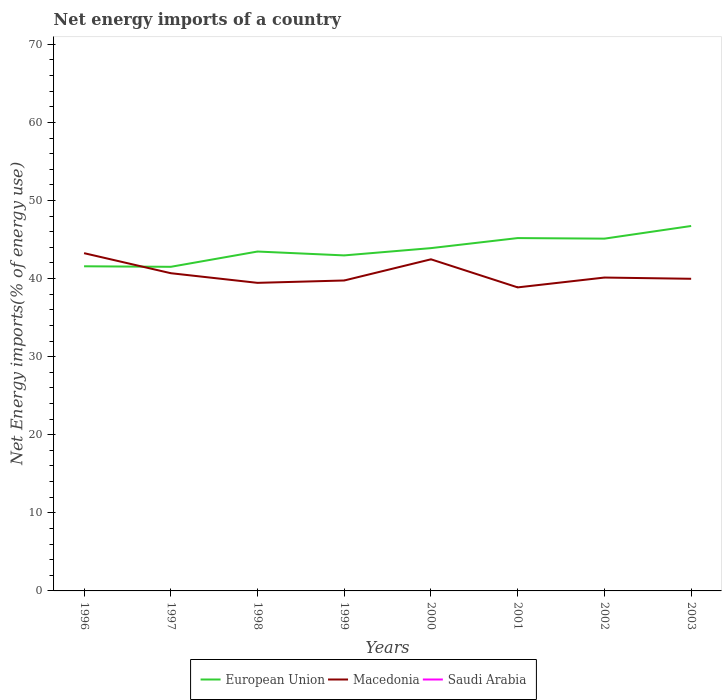How many different coloured lines are there?
Your answer should be very brief. 2. Is the number of lines equal to the number of legend labels?
Keep it short and to the point. No. What is the total net energy imports in European Union in the graph?
Make the answer very short. -1.29. What is the difference between the highest and the second highest net energy imports in Macedonia?
Ensure brevity in your answer.  4.38. What is the difference between the highest and the lowest net energy imports in Saudi Arabia?
Keep it short and to the point. 0. How many lines are there?
Make the answer very short. 2. What is the difference between two consecutive major ticks on the Y-axis?
Your answer should be compact. 10. Does the graph contain any zero values?
Keep it short and to the point. Yes. Does the graph contain grids?
Provide a succinct answer. No. How many legend labels are there?
Provide a succinct answer. 3. How are the legend labels stacked?
Offer a very short reply. Horizontal. What is the title of the graph?
Provide a succinct answer. Net energy imports of a country. What is the label or title of the X-axis?
Offer a terse response. Years. What is the label or title of the Y-axis?
Provide a short and direct response. Net Energy imports(% of energy use). What is the Net Energy imports(% of energy use) of European Union in 1996?
Your answer should be very brief. 41.58. What is the Net Energy imports(% of energy use) in Macedonia in 1996?
Keep it short and to the point. 43.26. What is the Net Energy imports(% of energy use) of Saudi Arabia in 1996?
Keep it short and to the point. 0. What is the Net Energy imports(% of energy use) of European Union in 1997?
Give a very brief answer. 41.51. What is the Net Energy imports(% of energy use) in Macedonia in 1997?
Make the answer very short. 40.69. What is the Net Energy imports(% of energy use) in European Union in 1998?
Your answer should be compact. 43.47. What is the Net Energy imports(% of energy use) of Macedonia in 1998?
Give a very brief answer. 39.46. What is the Net Energy imports(% of energy use) in Saudi Arabia in 1998?
Provide a short and direct response. 0. What is the Net Energy imports(% of energy use) of European Union in 1999?
Keep it short and to the point. 42.97. What is the Net Energy imports(% of energy use) in Macedonia in 1999?
Make the answer very short. 39.76. What is the Net Energy imports(% of energy use) of Saudi Arabia in 1999?
Your answer should be very brief. 0. What is the Net Energy imports(% of energy use) of European Union in 2000?
Offer a very short reply. 43.9. What is the Net Energy imports(% of energy use) of Macedonia in 2000?
Give a very brief answer. 42.47. What is the Net Energy imports(% of energy use) in Saudi Arabia in 2000?
Offer a terse response. 0. What is the Net Energy imports(% of energy use) in European Union in 2001?
Keep it short and to the point. 45.19. What is the Net Energy imports(% of energy use) of Macedonia in 2001?
Your response must be concise. 38.87. What is the Net Energy imports(% of energy use) of Saudi Arabia in 2001?
Provide a succinct answer. 0. What is the Net Energy imports(% of energy use) in European Union in 2002?
Offer a very short reply. 45.12. What is the Net Energy imports(% of energy use) of Macedonia in 2002?
Provide a succinct answer. 40.14. What is the Net Energy imports(% of energy use) in Saudi Arabia in 2002?
Provide a succinct answer. 0. What is the Net Energy imports(% of energy use) in European Union in 2003?
Your answer should be very brief. 46.74. What is the Net Energy imports(% of energy use) in Macedonia in 2003?
Make the answer very short. 39.98. What is the Net Energy imports(% of energy use) of Saudi Arabia in 2003?
Ensure brevity in your answer.  0. Across all years, what is the maximum Net Energy imports(% of energy use) in European Union?
Make the answer very short. 46.74. Across all years, what is the maximum Net Energy imports(% of energy use) of Macedonia?
Your response must be concise. 43.26. Across all years, what is the minimum Net Energy imports(% of energy use) in European Union?
Your answer should be very brief. 41.51. Across all years, what is the minimum Net Energy imports(% of energy use) of Macedonia?
Ensure brevity in your answer.  38.87. What is the total Net Energy imports(% of energy use) of European Union in the graph?
Give a very brief answer. 350.48. What is the total Net Energy imports(% of energy use) in Macedonia in the graph?
Offer a very short reply. 324.62. What is the difference between the Net Energy imports(% of energy use) in European Union in 1996 and that in 1997?
Your answer should be compact. 0.07. What is the difference between the Net Energy imports(% of energy use) in Macedonia in 1996 and that in 1997?
Provide a succinct answer. 2.57. What is the difference between the Net Energy imports(% of energy use) of European Union in 1996 and that in 1998?
Give a very brief answer. -1.89. What is the difference between the Net Energy imports(% of energy use) in Macedonia in 1996 and that in 1998?
Ensure brevity in your answer.  3.8. What is the difference between the Net Energy imports(% of energy use) in European Union in 1996 and that in 1999?
Keep it short and to the point. -1.39. What is the difference between the Net Energy imports(% of energy use) of Macedonia in 1996 and that in 1999?
Keep it short and to the point. 3.5. What is the difference between the Net Energy imports(% of energy use) of European Union in 1996 and that in 2000?
Make the answer very short. -2.32. What is the difference between the Net Energy imports(% of energy use) of Macedonia in 1996 and that in 2000?
Your response must be concise. 0.79. What is the difference between the Net Energy imports(% of energy use) of European Union in 1996 and that in 2001?
Ensure brevity in your answer.  -3.61. What is the difference between the Net Energy imports(% of energy use) in Macedonia in 1996 and that in 2001?
Offer a terse response. 4.38. What is the difference between the Net Energy imports(% of energy use) of European Union in 1996 and that in 2002?
Provide a short and direct response. -3.54. What is the difference between the Net Energy imports(% of energy use) in Macedonia in 1996 and that in 2002?
Keep it short and to the point. 3.12. What is the difference between the Net Energy imports(% of energy use) in European Union in 1996 and that in 2003?
Your response must be concise. -5.16. What is the difference between the Net Energy imports(% of energy use) in Macedonia in 1996 and that in 2003?
Your answer should be very brief. 3.28. What is the difference between the Net Energy imports(% of energy use) of European Union in 1997 and that in 1998?
Make the answer very short. -1.96. What is the difference between the Net Energy imports(% of energy use) in Macedonia in 1997 and that in 1998?
Provide a short and direct response. 1.24. What is the difference between the Net Energy imports(% of energy use) in European Union in 1997 and that in 1999?
Keep it short and to the point. -1.46. What is the difference between the Net Energy imports(% of energy use) of Macedonia in 1997 and that in 1999?
Your response must be concise. 0.93. What is the difference between the Net Energy imports(% of energy use) in European Union in 1997 and that in 2000?
Provide a succinct answer. -2.39. What is the difference between the Net Energy imports(% of energy use) in Macedonia in 1997 and that in 2000?
Provide a short and direct response. -1.78. What is the difference between the Net Energy imports(% of energy use) of European Union in 1997 and that in 2001?
Offer a terse response. -3.68. What is the difference between the Net Energy imports(% of energy use) in Macedonia in 1997 and that in 2001?
Provide a short and direct response. 1.82. What is the difference between the Net Energy imports(% of energy use) in European Union in 1997 and that in 2002?
Offer a terse response. -3.61. What is the difference between the Net Energy imports(% of energy use) in Macedonia in 1997 and that in 2002?
Offer a terse response. 0.56. What is the difference between the Net Energy imports(% of energy use) of European Union in 1997 and that in 2003?
Provide a succinct answer. -5.23. What is the difference between the Net Energy imports(% of energy use) of Macedonia in 1997 and that in 2003?
Give a very brief answer. 0.71. What is the difference between the Net Energy imports(% of energy use) of European Union in 1998 and that in 1999?
Make the answer very short. 0.5. What is the difference between the Net Energy imports(% of energy use) in Macedonia in 1998 and that in 1999?
Provide a short and direct response. -0.3. What is the difference between the Net Energy imports(% of energy use) of European Union in 1998 and that in 2000?
Your response must be concise. -0.44. What is the difference between the Net Energy imports(% of energy use) in Macedonia in 1998 and that in 2000?
Your answer should be compact. -3.02. What is the difference between the Net Energy imports(% of energy use) in European Union in 1998 and that in 2001?
Provide a short and direct response. -1.72. What is the difference between the Net Energy imports(% of energy use) in Macedonia in 1998 and that in 2001?
Provide a short and direct response. 0.58. What is the difference between the Net Energy imports(% of energy use) of European Union in 1998 and that in 2002?
Provide a succinct answer. -1.65. What is the difference between the Net Energy imports(% of energy use) of Macedonia in 1998 and that in 2002?
Your answer should be compact. -0.68. What is the difference between the Net Energy imports(% of energy use) in European Union in 1998 and that in 2003?
Your response must be concise. -3.27. What is the difference between the Net Energy imports(% of energy use) of Macedonia in 1998 and that in 2003?
Your answer should be compact. -0.52. What is the difference between the Net Energy imports(% of energy use) of European Union in 1999 and that in 2000?
Keep it short and to the point. -0.93. What is the difference between the Net Energy imports(% of energy use) in Macedonia in 1999 and that in 2000?
Your answer should be very brief. -2.71. What is the difference between the Net Energy imports(% of energy use) in European Union in 1999 and that in 2001?
Your answer should be compact. -2.22. What is the difference between the Net Energy imports(% of energy use) of Macedonia in 1999 and that in 2001?
Keep it short and to the point. 0.88. What is the difference between the Net Energy imports(% of energy use) of European Union in 1999 and that in 2002?
Ensure brevity in your answer.  -2.15. What is the difference between the Net Energy imports(% of energy use) of Macedonia in 1999 and that in 2002?
Your answer should be very brief. -0.38. What is the difference between the Net Energy imports(% of energy use) of European Union in 1999 and that in 2003?
Give a very brief answer. -3.77. What is the difference between the Net Energy imports(% of energy use) of Macedonia in 1999 and that in 2003?
Offer a very short reply. -0.22. What is the difference between the Net Energy imports(% of energy use) in European Union in 2000 and that in 2001?
Provide a short and direct response. -1.29. What is the difference between the Net Energy imports(% of energy use) of Macedonia in 2000 and that in 2001?
Offer a terse response. 3.6. What is the difference between the Net Energy imports(% of energy use) of European Union in 2000 and that in 2002?
Keep it short and to the point. -1.21. What is the difference between the Net Energy imports(% of energy use) of Macedonia in 2000 and that in 2002?
Offer a terse response. 2.34. What is the difference between the Net Energy imports(% of energy use) in European Union in 2000 and that in 2003?
Your answer should be very brief. -2.84. What is the difference between the Net Energy imports(% of energy use) in Macedonia in 2000 and that in 2003?
Your response must be concise. 2.49. What is the difference between the Net Energy imports(% of energy use) in European Union in 2001 and that in 2002?
Make the answer very short. 0.07. What is the difference between the Net Energy imports(% of energy use) of Macedonia in 2001 and that in 2002?
Give a very brief answer. -1.26. What is the difference between the Net Energy imports(% of energy use) in European Union in 2001 and that in 2003?
Ensure brevity in your answer.  -1.55. What is the difference between the Net Energy imports(% of energy use) in Macedonia in 2001 and that in 2003?
Your answer should be compact. -1.1. What is the difference between the Net Energy imports(% of energy use) in European Union in 2002 and that in 2003?
Provide a short and direct response. -1.62. What is the difference between the Net Energy imports(% of energy use) in Macedonia in 2002 and that in 2003?
Your answer should be very brief. 0.16. What is the difference between the Net Energy imports(% of energy use) in European Union in 1996 and the Net Energy imports(% of energy use) in Macedonia in 1997?
Provide a short and direct response. 0.89. What is the difference between the Net Energy imports(% of energy use) of European Union in 1996 and the Net Energy imports(% of energy use) of Macedonia in 1998?
Make the answer very short. 2.12. What is the difference between the Net Energy imports(% of energy use) of European Union in 1996 and the Net Energy imports(% of energy use) of Macedonia in 1999?
Your response must be concise. 1.82. What is the difference between the Net Energy imports(% of energy use) in European Union in 1996 and the Net Energy imports(% of energy use) in Macedonia in 2000?
Offer a terse response. -0.89. What is the difference between the Net Energy imports(% of energy use) of European Union in 1996 and the Net Energy imports(% of energy use) of Macedonia in 2001?
Offer a very short reply. 2.7. What is the difference between the Net Energy imports(% of energy use) of European Union in 1996 and the Net Energy imports(% of energy use) of Macedonia in 2002?
Give a very brief answer. 1.44. What is the difference between the Net Energy imports(% of energy use) of European Union in 1996 and the Net Energy imports(% of energy use) of Macedonia in 2003?
Give a very brief answer. 1.6. What is the difference between the Net Energy imports(% of energy use) in European Union in 1997 and the Net Energy imports(% of energy use) in Macedonia in 1998?
Make the answer very short. 2.05. What is the difference between the Net Energy imports(% of energy use) of European Union in 1997 and the Net Energy imports(% of energy use) of Macedonia in 1999?
Ensure brevity in your answer.  1.75. What is the difference between the Net Energy imports(% of energy use) of European Union in 1997 and the Net Energy imports(% of energy use) of Macedonia in 2000?
Your response must be concise. -0.96. What is the difference between the Net Energy imports(% of energy use) in European Union in 1997 and the Net Energy imports(% of energy use) in Macedonia in 2001?
Keep it short and to the point. 2.64. What is the difference between the Net Energy imports(% of energy use) in European Union in 1997 and the Net Energy imports(% of energy use) in Macedonia in 2002?
Offer a very short reply. 1.37. What is the difference between the Net Energy imports(% of energy use) in European Union in 1997 and the Net Energy imports(% of energy use) in Macedonia in 2003?
Make the answer very short. 1.53. What is the difference between the Net Energy imports(% of energy use) of European Union in 1998 and the Net Energy imports(% of energy use) of Macedonia in 1999?
Give a very brief answer. 3.71. What is the difference between the Net Energy imports(% of energy use) of European Union in 1998 and the Net Energy imports(% of energy use) of Macedonia in 2000?
Provide a succinct answer. 1. What is the difference between the Net Energy imports(% of energy use) in European Union in 1998 and the Net Energy imports(% of energy use) in Macedonia in 2001?
Provide a succinct answer. 4.59. What is the difference between the Net Energy imports(% of energy use) in European Union in 1998 and the Net Energy imports(% of energy use) in Macedonia in 2002?
Offer a very short reply. 3.33. What is the difference between the Net Energy imports(% of energy use) of European Union in 1998 and the Net Energy imports(% of energy use) of Macedonia in 2003?
Ensure brevity in your answer.  3.49. What is the difference between the Net Energy imports(% of energy use) in European Union in 1999 and the Net Energy imports(% of energy use) in Macedonia in 2001?
Provide a succinct answer. 4.1. What is the difference between the Net Energy imports(% of energy use) of European Union in 1999 and the Net Energy imports(% of energy use) of Macedonia in 2002?
Provide a short and direct response. 2.84. What is the difference between the Net Energy imports(% of energy use) in European Union in 1999 and the Net Energy imports(% of energy use) in Macedonia in 2003?
Your answer should be compact. 2.99. What is the difference between the Net Energy imports(% of energy use) in European Union in 2000 and the Net Energy imports(% of energy use) in Macedonia in 2001?
Ensure brevity in your answer.  5.03. What is the difference between the Net Energy imports(% of energy use) in European Union in 2000 and the Net Energy imports(% of energy use) in Macedonia in 2002?
Your answer should be very brief. 3.77. What is the difference between the Net Energy imports(% of energy use) in European Union in 2000 and the Net Energy imports(% of energy use) in Macedonia in 2003?
Provide a short and direct response. 3.93. What is the difference between the Net Energy imports(% of energy use) in European Union in 2001 and the Net Energy imports(% of energy use) in Macedonia in 2002?
Provide a succinct answer. 5.06. What is the difference between the Net Energy imports(% of energy use) in European Union in 2001 and the Net Energy imports(% of energy use) in Macedonia in 2003?
Keep it short and to the point. 5.21. What is the difference between the Net Energy imports(% of energy use) in European Union in 2002 and the Net Energy imports(% of energy use) in Macedonia in 2003?
Ensure brevity in your answer.  5.14. What is the average Net Energy imports(% of energy use) in European Union per year?
Offer a very short reply. 43.81. What is the average Net Energy imports(% of energy use) in Macedonia per year?
Provide a succinct answer. 40.58. What is the average Net Energy imports(% of energy use) in Saudi Arabia per year?
Offer a terse response. 0. In the year 1996, what is the difference between the Net Energy imports(% of energy use) of European Union and Net Energy imports(% of energy use) of Macedonia?
Provide a short and direct response. -1.68. In the year 1997, what is the difference between the Net Energy imports(% of energy use) of European Union and Net Energy imports(% of energy use) of Macedonia?
Ensure brevity in your answer.  0.82. In the year 1998, what is the difference between the Net Energy imports(% of energy use) of European Union and Net Energy imports(% of energy use) of Macedonia?
Offer a very short reply. 4.01. In the year 1999, what is the difference between the Net Energy imports(% of energy use) in European Union and Net Energy imports(% of energy use) in Macedonia?
Provide a short and direct response. 3.21. In the year 2000, what is the difference between the Net Energy imports(% of energy use) of European Union and Net Energy imports(% of energy use) of Macedonia?
Your response must be concise. 1.43. In the year 2001, what is the difference between the Net Energy imports(% of energy use) in European Union and Net Energy imports(% of energy use) in Macedonia?
Provide a succinct answer. 6.32. In the year 2002, what is the difference between the Net Energy imports(% of energy use) of European Union and Net Energy imports(% of energy use) of Macedonia?
Offer a very short reply. 4.98. In the year 2003, what is the difference between the Net Energy imports(% of energy use) of European Union and Net Energy imports(% of energy use) of Macedonia?
Ensure brevity in your answer.  6.76. What is the ratio of the Net Energy imports(% of energy use) in European Union in 1996 to that in 1997?
Offer a terse response. 1. What is the ratio of the Net Energy imports(% of energy use) of Macedonia in 1996 to that in 1997?
Offer a terse response. 1.06. What is the ratio of the Net Energy imports(% of energy use) in European Union in 1996 to that in 1998?
Your response must be concise. 0.96. What is the ratio of the Net Energy imports(% of energy use) of Macedonia in 1996 to that in 1998?
Give a very brief answer. 1.1. What is the ratio of the Net Energy imports(% of energy use) of European Union in 1996 to that in 1999?
Ensure brevity in your answer.  0.97. What is the ratio of the Net Energy imports(% of energy use) of Macedonia in 1996 to that in 1999?
Provide a short and direct response. 1.09. What is the ratio of the Net Energy imports(% of energy use) in European Union in 1996 to that in 2000?
Offer a terse response. 0.95. What is the ratio of the Net Energy imports(% of energy use) of Macedonia in 1996 to that in 2000?
Provide a short and direct response. 1.02. What is the ratio of the Net Energy imports(% of energy use) in European Union in 1996 to that in 2001?
Offer a very short reply. 0.92. What is the ratio of the Net Energy imports(% of energy use) in Macedonia in 1996 to that in 2001?
Offer a terse response. 1.11. What is the ratio of the Net Energy imports(% of energy use) of European Union in 1996 to that in 2002?
Ensure brevity in your answer.  0.92. What is the ratio of the Net Energy imports(% of energy use) in Macedonia in 1996 to that in 2002?
Provide a short and direct response. 1.08. What is the ratio of the Net Energy imports(% of energy use) in European Union in 1996 to that in 2003?
Your response must be concise. 0.89. What is the ratio of the Net Energy imports(% of energy use) of Macedonia in 1996 to that in 2003?
Give a very brief answer. 1.08. What is the ratio of the Net Energy imports(% of energy use) in European Union in 1997 to that in 1998?
Your response must be concise. 0.95. What is the ratio of the Net Energy imports(% of energy use) of Macedonia in 1997 to that in 1998?
Provide a short and direct response. 1.03. What is the ratio of the Net Energy imports(% of energy use) of Macedonia in 1997 to that in 1999?
Your answer should be compact. 1.02. What is the ratio of the Net Energy imports(% of energy use) of European Union in 1997 to that in 2000?
Offer a terse response. 0.95. What is the ratio of the Net Energy imports(% of energy use) of Macedonia in 1997 to that in 2000?
Offer a very short reply. 0.96. What is the ratio of the Net Energy imports(% of energy use) in European Union in 1997 to that in 2001?
Make the answer very short. 0.92. What is the ratio of the Net Energy imports(% of energy use) in Macedonia in 1997 to that in 2001?
Ensure brevity in your answer.  1.05. What is the ratio of the Net Energy imports(% of energy use) of European Union in 1997 to that in 2002?
Your response must be concise. 0.92. What is the ratio of the Net Energy imports(% of energy use) of Macedonia in 1997 to that in 2002?
Your answer should be compact. 1.01. What is the ratio of the Net Energy imports(% of energy use) in European Union in 1997 to that in 2003?
Provide a succinct answer. 0.89. What is the ratio of the Net Energy imports(% of energy use) in Macedonia in 1997 to that in 2003?
Provide a succinct answer. 1.02. What is the ratio of the Net Energy imports(% of energy use) of European Union in 1998 to that in 1999?
Make the answer very short. 1.01. What is the ratio of the Net Energy imports(% of energy use) of Macedonia in 1998 to that in 2000?
Provide a succinct answer. 0.93. What is the ratio of the Net Energy imports(% of energy use) of European Union in 1998 to that in 2001?
Provide a succinct answer. 0.96. What is the ratio of the Net Energy imports(% of energy use) of European Union in 1998 to that in 2002?
Make the answer very short. 0.96. What is the ratio of the Net Energy imports(% of energy use) of Macedonia in 1998 to that in 2002?
Your answer should be compact. 0.98. What is the ratio of the Net Energy imports(% of energy use) in European Union in 1998 to that in 2003?
Ensure brevity in your answer.  0.93. What is the ratio of the Net Energy imports(% of energy use) of European Union in 1999 to that in 2000?
Your answer should be compact. 0.98. What is the ratio of the Net Energy imports(% of energy use) of Macedonia in 1999 to that in 2000?
Give a very brief answer. 0.94. What is the ratio of the Net Energy imports(% of energy use) of European Union in 1999 to that in 2001?
Offer a very short reply. 0.95. What is the ratio of the Net Energy imports(% of energy use) in Macedonia in 1999 to that in 2001?
Make the answer very short. 1.02. What is the ratio of the Net Energy imports(% of energy use) of European Union in 1999 to that in 2002?
Provide a succinct answer. 0.95. What is the ratio of the Net Energy imports(% of energy use) of Macedonia in 1999 to that in 2002?
Your response must be concise. 0.99. What is the ratio of the Net Energy imports(% of energy use) in European Union in 1999 to that in 2003?
Make the answer very short. 0.92. What is the ratio of the Net Energy imports(% of energy use) in European Union in 2000 to that in 2001?
Your response must be concise. 0.97. What is the ratio of the Net Energy imports(% of energy use) of Macedonia in 2000 to that in 2001?
Provide a short and direct response. 1.09. What is the ratio of the Net Energy imports(% of energy use) in European Union in 2000 to that in 2002?
Provide a succinct answer. 0.97. What is the ratio of the Net Energy imports(% of energy use) in Macedonia in 2000 to that in 2002?
Provide a short and direct response. 1.06. What is the ratio of the Net Energy imports(% of energy use) in European Union in 2000 to that in 2003?
Keep it short and to the point. 0.94. What is the ratio of the Net Energy imports(% of energy use) of Macedonia in 2000 to that in 2003?
Make the answer very short. 1.06. What is the ratio of the Net Energy imports(% of energy use) in Macedonia in 2001 to that in 2002?
Your answer should be very brief. 0.97. What is the ratio of the Net Energy imports(% of energy use) of European Union in 2001 to that in 2003?
Your answer should be very brief. 0.97. What is the ratio of the Net Energy imports(% of energy use) of Macedonia in 2001 to that in 2003?
Your response must be concise. 0.97. What is the ratio of the Net Energy imports(% of energy use) of European Union in 2002 to that in 2003?
Ensure brevity in your answer.  0.97. What is the difference between the highest and the second highest Net Energy imports(% of energy use) of European Union?
Provide a short and direct response. 1.55. What is the difference between the highest and the second highest Net Energy imports(% of energy use) of Macedonia?
Your answer should be very brief. 0.79. What is the difference between the highest and the lowest Net Energy imports(% of energy use) of European Union?
Offer a terse response. 5.23. What is the difference between the highest and the lowest Net Energy imports(% of energy use) of Macedonia?
Your answer should be compact. 4.38. 